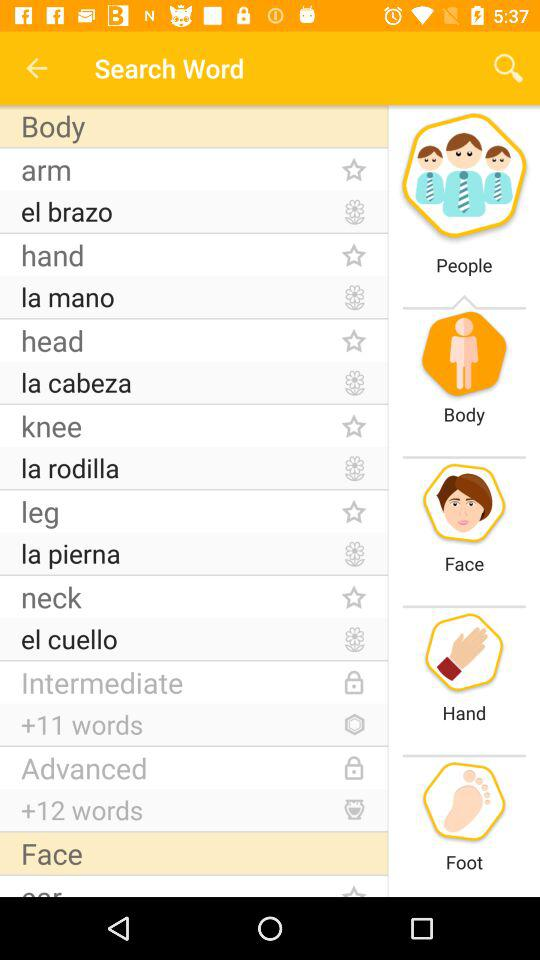What is the count of words in "Intermediate"? There are 11 words in "Intermediate". 